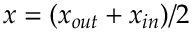<formula> <loc_0><loc_0><loc_500><loc_500>x = ( x _ { o u t } + x _ { i n } ) / 2</formula> 